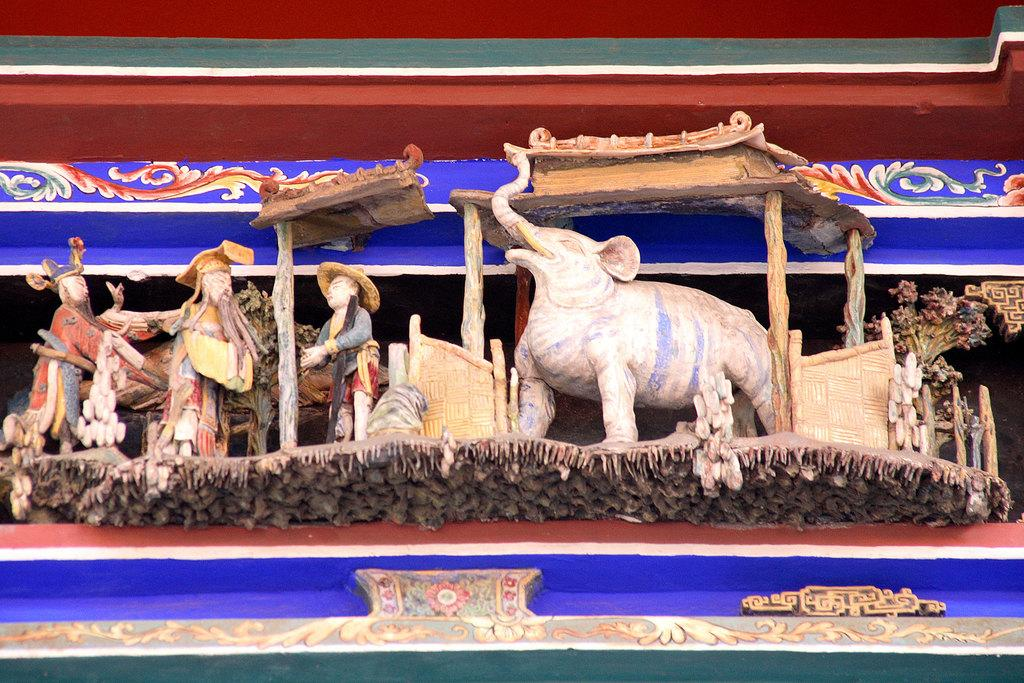What types of sculptures can be seen in the image? There are sculptures of people and animals in the image. What else is visible in the image besides the sculptures? There is a wall visible in the image. What type of berry is growing on the hill in the image? There is no hill or berry present in the image; it only features sculptures of people and animals and a wall. 